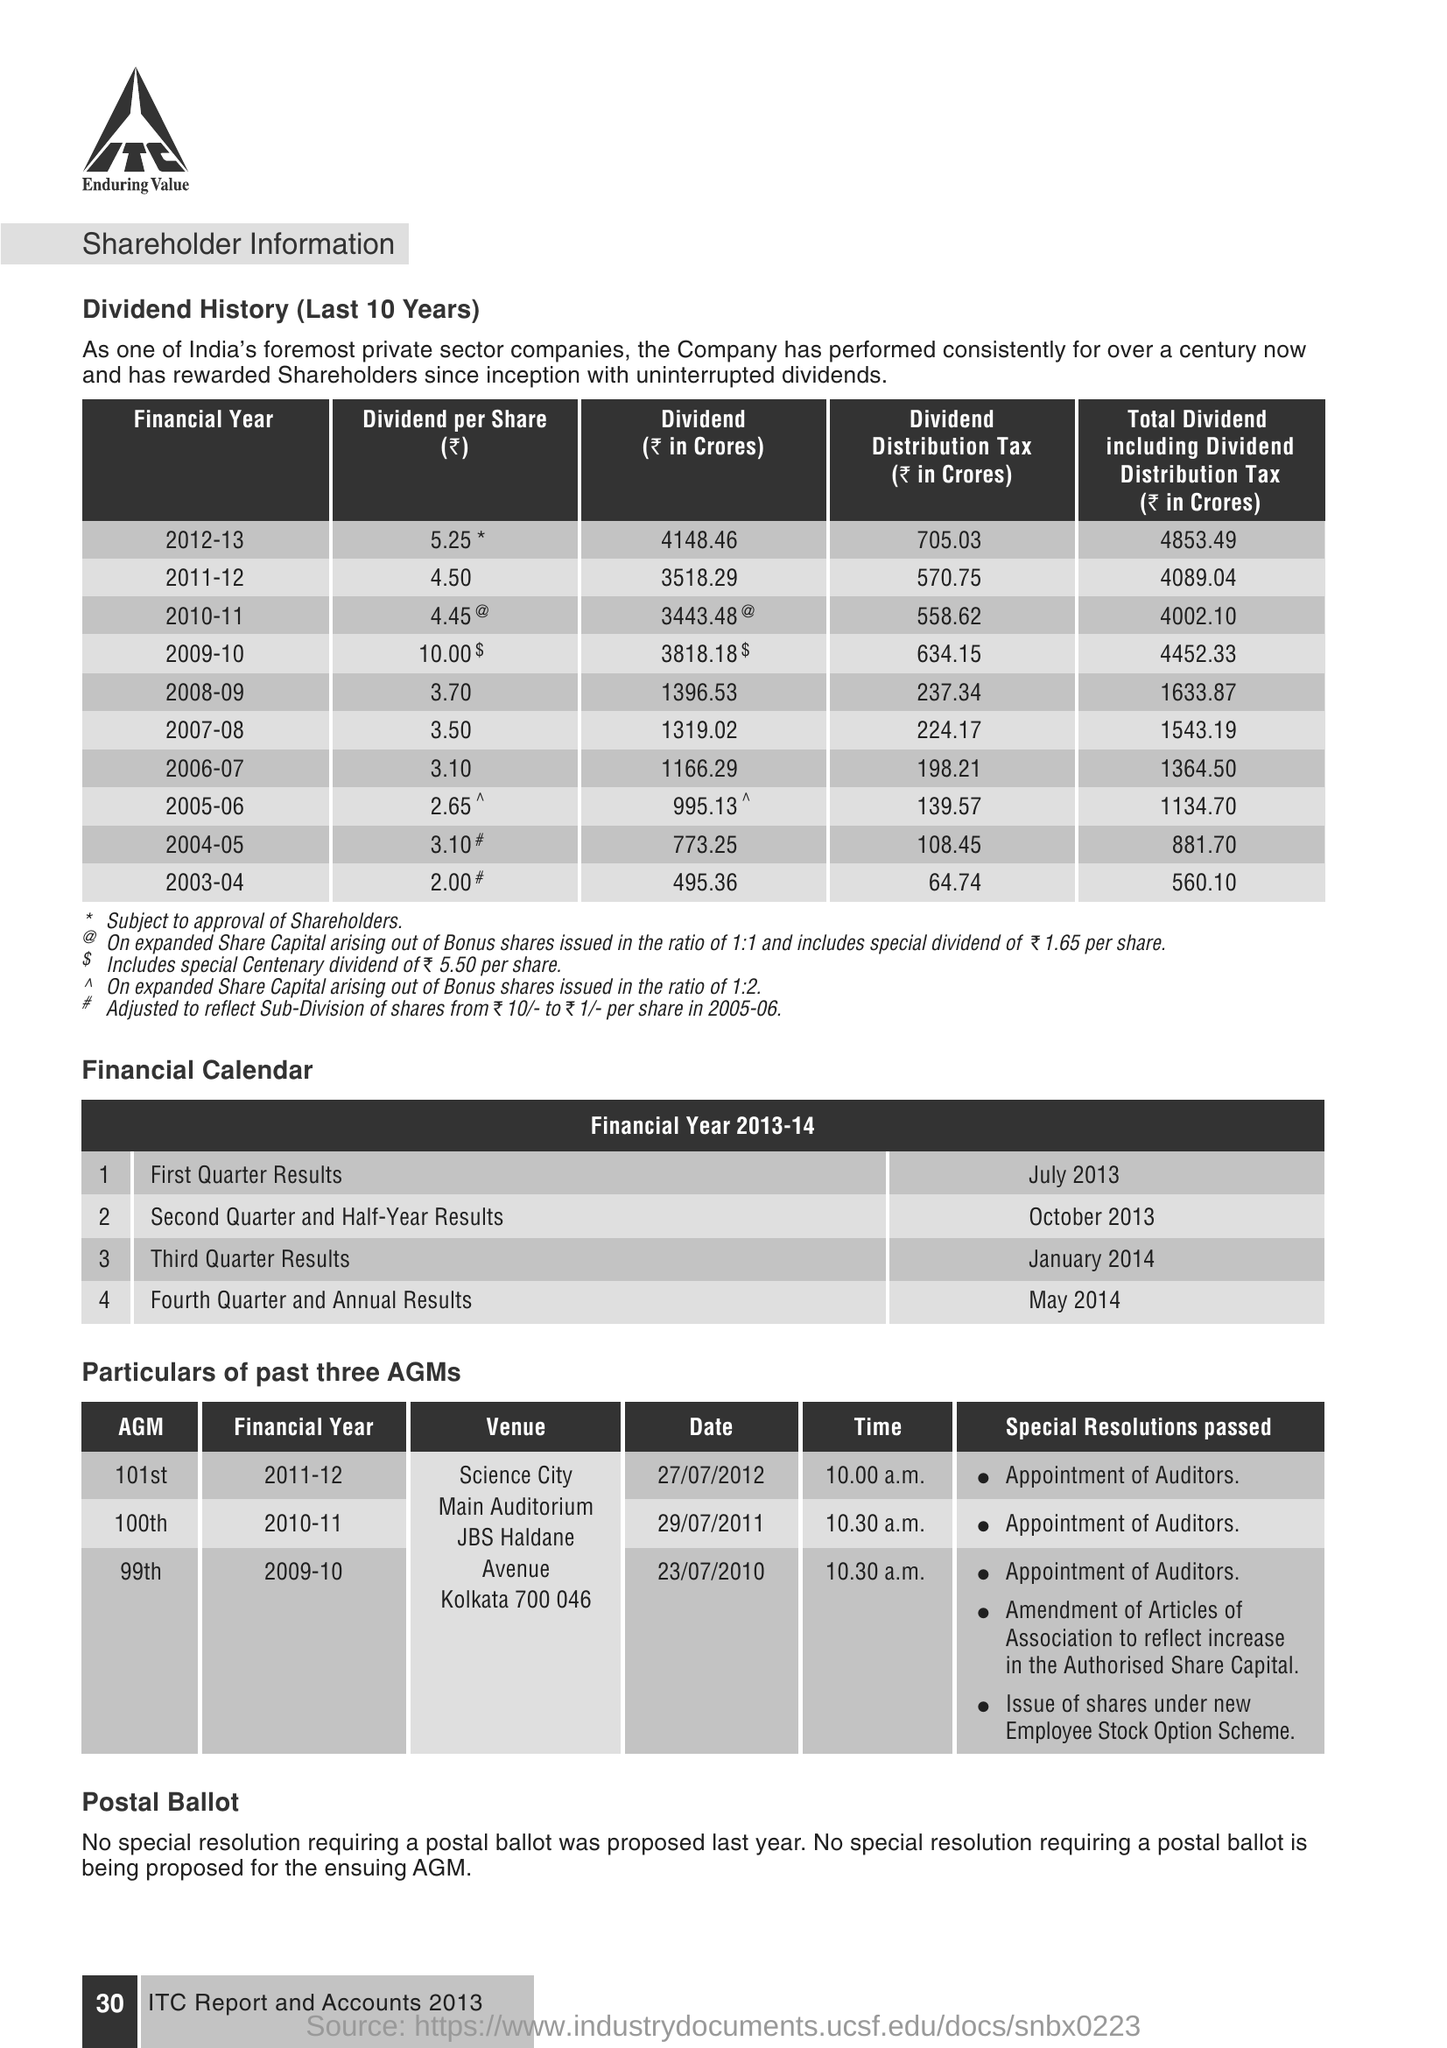What were the special resolutions passed during the 101st AGM? During the 101st AGM, the special resolutions passed included the appointment of auditors. 